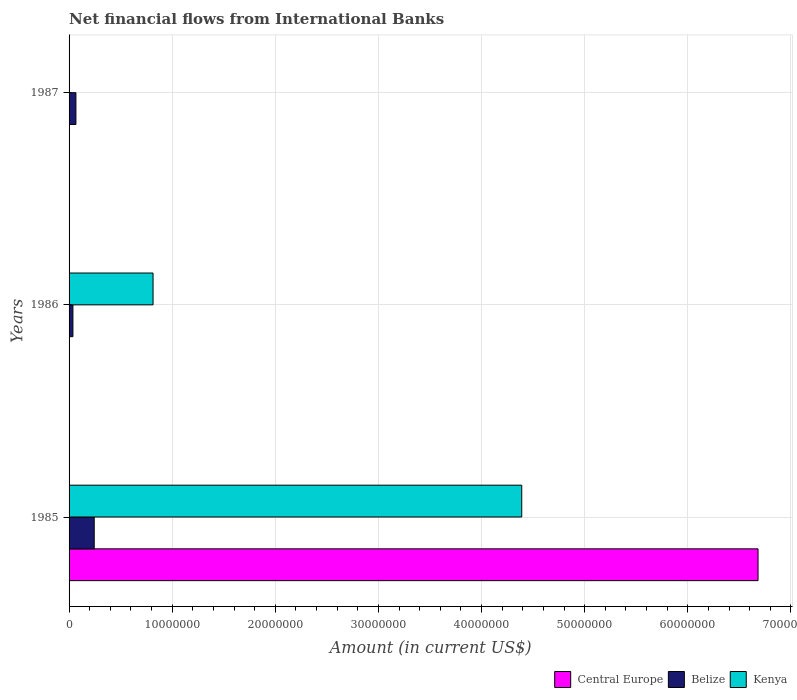Are the number of bars on each tick of the Y-axis equal?
Give a very brief answer. No. How many bars are there on the 1st tick from the bottom?
Make the answer very short. 3. What is the label of the 2nd group of bars from the top?
Your answer should be very brief. 1986. In how many cases, is the number of bars for a given year not equal to the number of legend labels?
Your answer should be compact. 2. What is the net financial aid flows in Central Europe in 1986?
Offer a very short reply. 0. Across all years, what is the maximum net financial aid flows in Belize?
Ensure brevity in your answer.  2.44e+06. In which year was the net financial aid flows in Kenya maximum?
Ensure brevity in your answer.  1985. What is the total net financial aid flows in Belize in the graph?
Provide a short and direct response. 3.48e+06. What is the difference between the net financial aid flows in Belize in 1985 and that in 1986?
Keep it short and to the point. 2.07e+06. What is the difference between the net financial aid flows in Belize in 1985 and the net financial aid flows in Kenya in 1986?
Your answer should be compact. -5.70e+06. What is the average net financial aid flows in Central Europe per year?
Your answer should be very brief. 2.23e+07. In the year 1985, what is the difference between the net financial aid flows in Belize and net financial aid flows in Kenya?
Provide a short and direct response. -4.15e+07. In how many years, is the net financial aid flows in Central Europe greater than 24000000 US$?
Your response must be concise. 1. What is the ratio of the net financial aid flows in Belize in 1985 to that in 1987?
Offer a very short reply. 3.67. Is the net financial aid flows in Kenya in 1985 less than that in 1986?
Provide a short and direct response. No. What is the difference between the highest and the second highest net financial aid flows in Belize?
Offer a very short reply. 1.77e+06. What is the difference between the highest and the lowest net financial aid flows in Kenya?
Your answer should be compact. 4.39e+07. Is the sum of the net financial aid flows in Belize in 1985 and 1987 greater than the maximum net financial aid flows in Kenya across all years?
Make the answer very short. No. Is it the case that in every year, the sum of the net financial aid flows in Central Europe and net financial aid flows in Belize is greater than the net financial aid flows in Kenya?
Your answer should be very brief. No. How many bars are there?
Your answer should be very brief. 6. Are the values on the major ticks of X-axis written in scientific E-notation?
Your answer should be very brief. No. Does the graph contain any zero values?
Offer a terse response. Yes. Does the graph contain grids?
Keep it short and to the point. Yes. What is the title of the graph?
Offer a very short reply. Net financial flows from International Banks. What is the Amount (in current US$) of Central Europe in 1985?
Provide a succinct answer. 6.68e+07. What is the Amount (in current US$) in Belize in 1985?
Your answer should be compact. 2.44e+06. What is the Amount (in current US$) of Kenya in 1985?
Make the answer very short. 4.39e+07. What is the Amount (in current US$) in Belize in 1986?
Your response must be concise. 3.73e+05. What is the Amount (in current US$) in Kenya in 1986?
Your answer should be compact. 8.14e+06. What is the Amount (in current US$) of Belize in 1987?
Keep it short and to the point. 6.65e+05. What is the Amount (in current US$) of Kenya in 1987?
Your answer should be compact. 0. Across all years, what is the maximum Amount (in current US$) in Central Europe?
Offer a very short reply. 6.68e+07. Across all years, what is the maximum Amount (in current US$) of Belize?
Provide a short and direct response. 2.44e+06. Across all years, what is the maximum Amount (in current US$) of Kenya?
Provide a short and direct response. 4.39e+07. Across all years, what is the minimum Amount (in current US$) of Belize?
Provide a succinct answer. 3.73e+05. Across all years, what is the minimum Amount (in current US$) in Kenya?
Keep it short and to the point. 0. What is the total Amount (in current US$) in Central Europe in the graph?
Make the answer very short. 6.68e+07. What is the total Amount (in current US$) of Belize in the graph?
Provide a succinct answer. 3.48e+06. What is the total Amount (in current US$) in Kenya in the graph?
Ensure brevity in your answer.  5.20e+07. What is the difference between the Amount (in current US$) in Belize in 1985 and that in 1986?
Ensure brevity in your answer.  2.07e+06. What is the difference between the Amount (in current US$) in Kenya in 1985 and that in 1986?
Provide a succinct answer. 3.58e+07. What is the difference between the Amount (in current US$) of Belize in 1985 and that in 1987?
Ensure brevity in your answer.  1.77e+06. What is the difference between the Amount (in current US$) in Belize in 1986 and that in 1987?
Your answer should be very brief. -2.92e+05. What is the difference between the Amount (in current US$) of Central Europe in 1985 and the Amount (in current US$) of Belize in 1986?
Give a very brief answer. 6.64e+07. What is the difference between the Amount (in current US$) in Central Europe in 1985 and the Amount (in current US$) in Kenya in 1986?
Provide a short and direct response. 5.87e+07. What is the difference between the Amount (in current US$) of Belize in 1985 and the Amount (in current US$) of Kenya in 1986?
Ensure brevity in your answer.  -5.70e+06. What is the difference between the Amount (in current US$) of Central Europe in 1985 and the Amount (in current US$) of Belize in 1987?
Your answer should be very brief. 6.62e+07. What is the average Amount (in current US$) of Central Europe per year?
Your response must be concise. 2.23e+07. What is the average Amount (in current US$) of Belize per year?
Offer a very short reply. 1.16e+06. What is the average Amount (in current US$) of Kenya per year?
Provide a short and direct response. 1.73e+07. In the year 1985, what is the difference between the Amount (in current US$) of Central Europe and Amount (in current US$) of Belize?
Give a very brief answer. 6.44e+07. In the year 1985, what is the difference between the Amount (in current US$) in Central Europe and Amount (in current US$) in Kenya?
Provide a succinct answer. 2.29e+07. In the year 1985, what is the difference between the Amount (in current US$) of Belize and Amount (in current US$) of Kenya?
Offer a terse response. -4.15e+07. In the year 1986, what is the difference between the Amount (in current US$) of Belize and Amount (in current US$) of Kenya?
Make the answer very short. -7.77e+06. What is the ratio of the Amount (in current US$) of Belize in 1985 to that in 1986?
Make the answer very short. 6.54. What is the ratio of the Amount (in current US$) in Kenya in 1985 to that in 1986?
Offer a very short reply. 5.39. What is the ratio of the Amount (in current US$) of Belize in 1985 to that in 1987?
Provide a succinct answer. 3.67. What is the ratio of the Amount (in current US$) in Belize in 1986 to that in 1987?
Offer a terse response. 0.56. What is the difference between the highest and the second highest Amount (in current US$) of Belize?
Provide a short and direct response. 1.77e+06. What is the difference between the highest and the lowest Amount (in current US$) in Central Europe?
Your answer should be very brief. 6.68e+07. What is the difference between the highest and the lowest Amount (in current US$) in Belize?
Keep it short and to the point. 2.07e+06. What is the difference between the highest and the lowest Amount (in current US$) in Kenya?
Provide a succinct answer. 4.39e+07. 